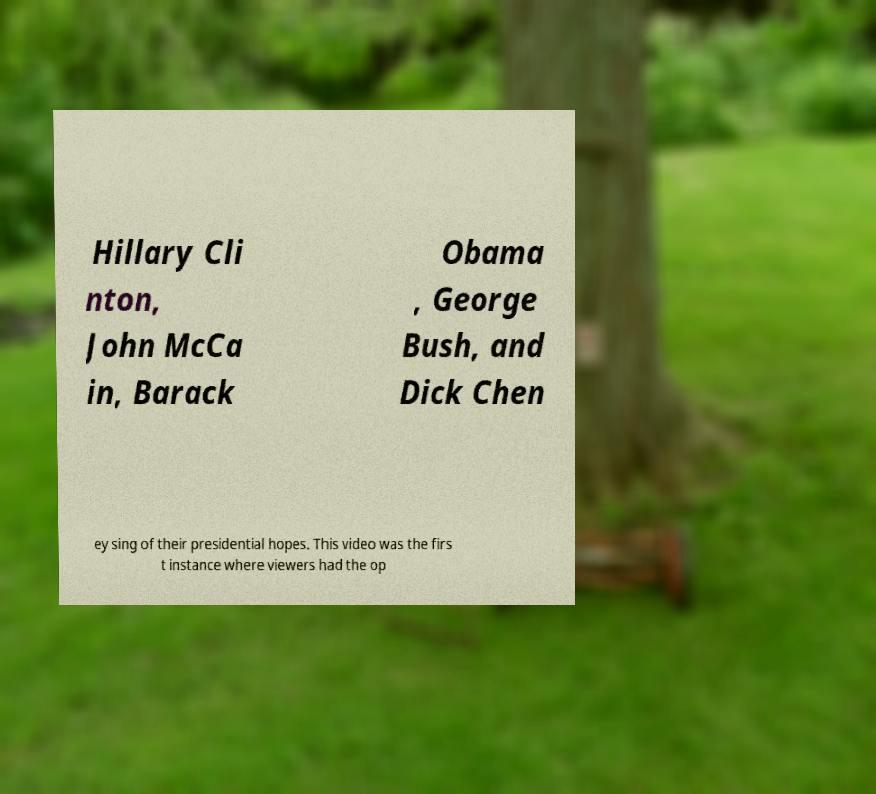Can you accurately transcribe the text from the provided image for me? Hillary Cli nton, John McCa in, Barack Obama , George Bush, and Dick Chen ey sing of their presidential hopes. This video was the firs t instance where viewers had the op 